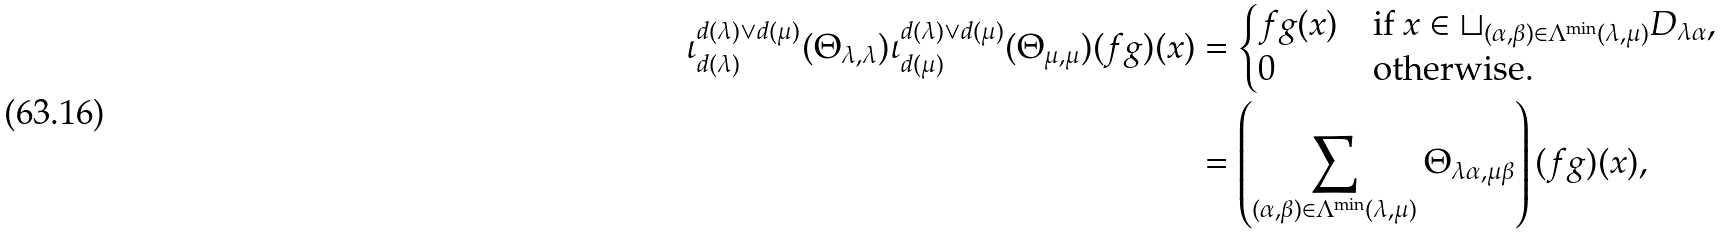Convert formula to latex. <formula><loc_0><loc_0><loc_500><loc_500>\iota _ { d ( \lambda ) } ^ { d ( \lambda ) \vee d ( \mu ) } ( \Theta _ { \lambda , \lambda } ) \iota _ { d ( \mu ) } ^ { d ( \lambda ) \vee d ( \mu ) } ( \Theta _ { \mu , \mu } ) ( f g ) ( x ) & = \begin{cases} f g ( x ) & \text {if $x\in \sqcup_{(\alpha,\beta)\in\Lambda^{\min}(\lambda,\mu)}D_{\lambda\alpha}$,} \\ 0 & \text {otherwise.} \end{cases} \\ & = \left ( \sum _ { ( \alpha , \beta ) \in \Lambda ^ { \min } ( \lambda , \mu ) } \Theta _ { \lambda \alpha , \mu \beta } \right ) ( f g ) ( x ) ,</formula> 